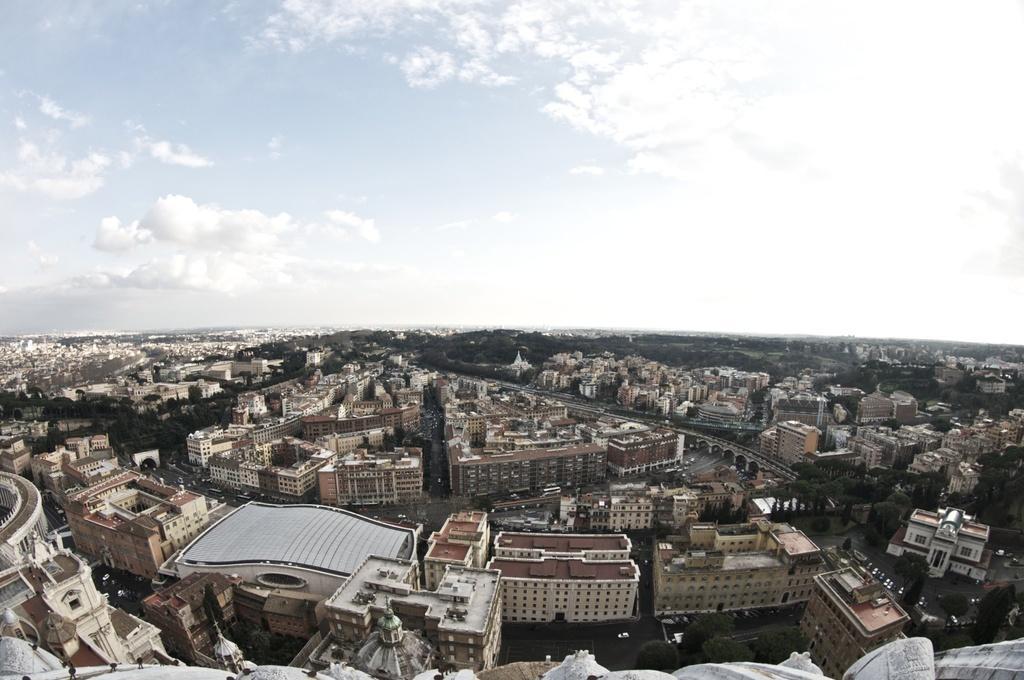Can you describe this image briefly? In this image there are buildings, trees, and the sky is cloudy. 